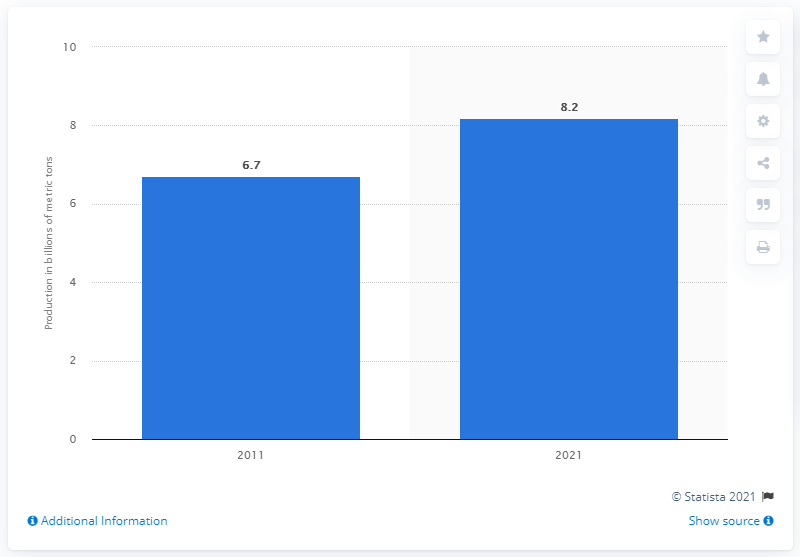Point out several critical features in this image. The projection for global agricultural production in 2021 is expected to be... The projected production of agricultural production for 2021 is expected to be 8.2. In 2011, the value of global agricultural production was calculated. In 2011, the total production of agricultural products was 6.7 million units. 